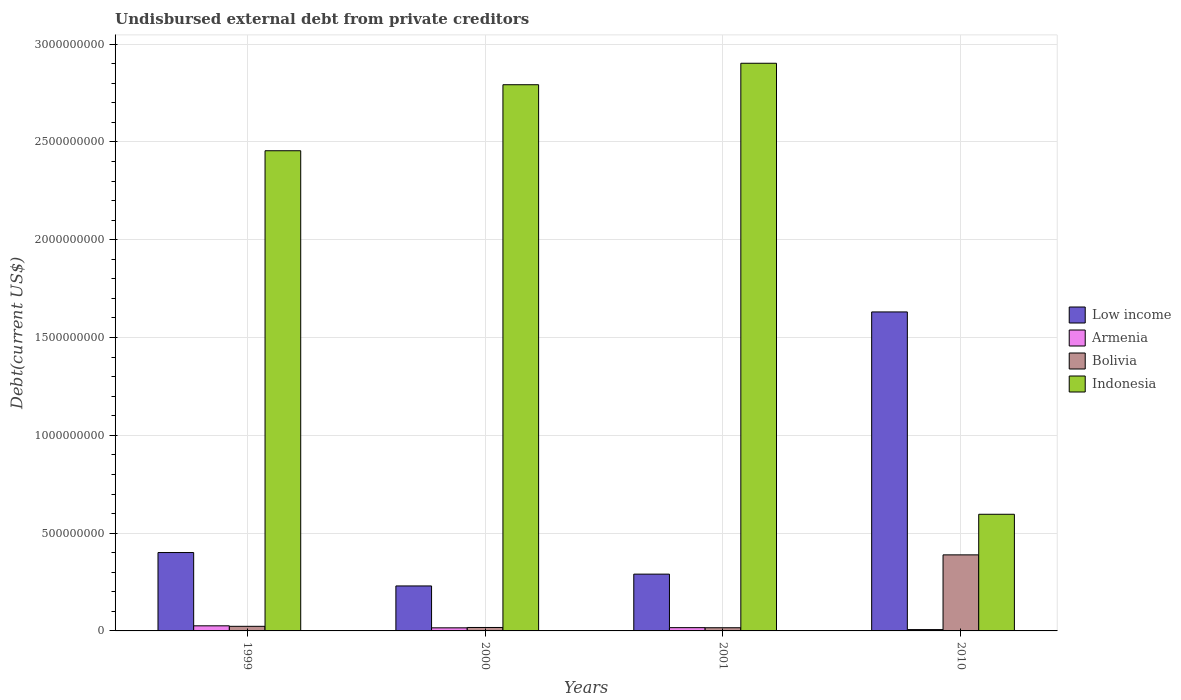Are the number of bars per tick equal to the number of legend labels?
Make the answer very short. Yes. How many bars are there on the 3rd tick from the left?
Provide a short and direct response. 4. What is the label of the 2nd group of bars from the left?
Provide a short and direct response. 2000. In how many cases, is the number of bars for a given year not equal to the number of legend labels?
Make the answer very short. 0. What is the total debt in Armenia in 2010?
Offer a terse response. 6.79e+06. Across all years, what is the maximum total debt in Low income?
Your response must be concise. 1.63e+09. Across all years, what is the minimum total debt in Low income?
Offer a very short reply. 2.30e+08. In which year was the total debt in Low income maximum?
Offer a terse response. 2010. What is the total total debt in Armenia in the graph?
Your answer should be very brief. 6.54e+07. What is the difference between the total debt in Armenia in 2000 and that in 2010?
Offer a terse response. 8.96e+06. What is the difference between the total debt in Indonesia in 2010 and the total debt in Bolivia in 1999?
Offer a very short reply. 5.73e+08. What is the average total debt in Low income per year?
Provide a short and direct response. 6.38e+08. In the year 2000, what is the difference between the total debt in Armenia and total debt in Low income?
Provide a short and direct response. -2.14e+08. What is the ratio of the total debt in Armenia in 1999 to that in 2010?
Offer a terse response. 3.85. Is the total debt in Bolivia in 2001 less than that in 2010?
Your answer should be very brief. Yes. What is the difference between the highest and the second highest total debt in Indonesia?
Your answer should be compact. 1.10e+08. What is the difference between the highest and the lowest total debt in Armenia?
Ensure brevity in your answer.  1.93e+07. Is it the case that in every year, the sum of the total debt in Armenia and total debt in Low income is greater than the sum of total debt in Bolivia and total debt in Indonesia?
Your answer should be compact. No. What does the 3rd bar from the left in 1999 represents?
Your answer should be compact. Bolivia. What does the 3rd bar from the right in 2001 represents?
Your answer should be compact. Armenia. How many bars are there?
Offer a very short reply. 16. Are all the bars in the graph horizontal?
Make the answer very short. No. What is the difference between two consecutive major ticks on the Y-axis?
Offer a very short reply. 5.00e+08. Does the graph contain any zero values?
Offer a terse response. No. What is the title of the graph?
Keep it short and to the point. Undisbursed external debt from private creditors. What is the label or title of the X-axis?
Your answer should be compact. Years. What is the label or title of the Y-axis?
Make the answer very short. Debt(current US$). What is the Debt(current US$) of Low income in 1999?
Your answer should be compact. 4.01e+08. What is the Debt(current US$) in Armenia in 1999?
Give a very brief answer. 2.61e+07. What is the Debt(current US$) of Bolivia in 1999?
Make the answer very short. 2.35e+07. What is the Debt(current US$) in Indonesia in 1999?
Give a very brief answer. 2.45e+09. What is the Debt(current US$) of Low income in 2000?
Your response must be concise. 2.30e+08. What is the Debt(current US$) in Armenia in 2000?
Your response must be concise. 1.58e+07. What is the Debt(current US$) in Bolivia in 2000?
Offer a very short reply. 1.76e+07. What is the Debt(current US$) of Indonesia in 2000?
Your answer should be very brief. 2.79e+09. What is the Debt(current US$) in Low income in 2001?
Keep it short and to the point. 2.90e+08. What is the Debt(current US$) in Armenia in 2001?
Make the answer very short. 1.67e+07. What is the Debt(current US$) in Bolivia in 2001?
Provide a succinct answer. 1.63e+07. What is the Debt(current US$) in Indonesia in 2001?
Give a very brief answer. 2.90e+09. What is the Debt(current US$) of Low income in 2010?
Your response must be concise. 1.63e+09. What is the Debt(current US$) of Armenia in 2010?
Keep it short and to the point. 6.79e+06. What is the Debt(current US$) in Bolivia in 2010?
Offer a very short reply. 3.89e+08. What is the Debt(current US$) of Indonesia in 2010?
Offer a very short reply. 5.96e+08. Across all years, what is the maximum Debt(current US$) in Low income?
Provide a succinct answer. 1.63e+09. Across all years, what is the maximum Debt(current US$) of Armenia?
Provide a short and direct response. 2.61e+07. Across all years, what is the maximum Debt(current US$) in Bolivia?
Provide a succinct answer. 3.89e+08. Across all years, what is the maximum Debt(current US$) of Indonesia?
Your answer should be very brief. 2.90e+09. Across all years, what is the minimum Debt(current US$) of Low income?
Make the answer very short. 2.30e+08. Across all years, what is the minimum Debt(current US$) in Armenia?
Your answer should be very brief. 6.79e+06. Across all years, what is the minimum Debt(current US$) in Bolivia?
Your response must be concise. 1.63e+07. Across all years, what is the minimum Debt(current US$) in Indonesia?
Your response must be concise. 5.96e+08. What is the total Debt(current US$) of Low income in the graph?
Keep it short and to the point. 2.55e+09. What is the total Debt(current US$) of Armenia in the graph?
Provide a short and direct response. 6.54e+07. What is the total Debt(current US$) of Bolivia in the graph?
Offer a very short reply. 4.46e+08. What is the total Debt(current US$) in Indonesia in the graph?
Your answer should be very brief. 8.75e+09. What is the difference between the Debt(current US$) of Low income in 1999 and that in 2000?
Keep it short and to the point. 1.71e+08. What is the difference between the Debt(current US$) in Armenia in 1999 and that in 2000?
Give a very brief answer. 1.04e+07. What is the difference between the Debt(current US$) of Bolivia in 1999 and that in 2000?
Your answer should be very brief. 5.89e+06. What is the difference between the Debt(current US$) of Indonesia in 1999 and that in 2000?
Make the answer very short. -3.38e+08. What is the difference between the Debt(current US$) in Low income in 1999 and that in 2001?
Offer a very short reply. 1.10e+08. What is the difference between the Debt(current US$) in Armenia in 1999 and that in 2001?
Give a very brief answer. 9.39e+06. What is the difference between the Debt(current US$) of Bolivia in 1999 and that in 2001?
Give a very brief answer. 7.24e+06. What is the difference between the Debt(current US$) of Indonesia in 1999 and that in 2001?
Offer a terse response. -4.47e+08. What is the difference between the Debt(current US$) in Low income in 1999 and that in 2010?
Make the answer very short. -1.23e+09. What is the difference between the Debt(current US$) of Armenia in 1999 and that in 2010?
Your response must be concise. 1.93e+07. What is the difference between the Debt(current US$) in Bolivia in 1999 and that in 2010?
Your answer should be compact. -3.65e+08. What is the difference between the Debt(current US$) of Indonesia in 1999 and that in 2010?
Offer a terse response. 1.86e+09. What is the difference between the Debt(current US$) of Low income in 2000 and that in 2001?
Offer a very short reply. -6.04e+07. What is the difference between the Debt(current US$) of Armenia in 2000 and that in 2001?
Provide a succinct answer. -9.60e+05. What is the difference between the Debt(current US$) of Bolivia in 2000 and that in 2001?
Keep it short and to the point. 1.35e+06. What is the difference between the Debt(current US$) of Indonesia in 2000 and that in 2001?
Provide a succinct answer. -1.10e+08. What is the difference between the Debt(current US$) of Low income in 2000 and that in 2010?
Your answer should be compact. -1.40e+09. What is the difference between the Debt(current US$) of Armenia in 2000 and that in 2010?
Your answer should be very brief. 8.96e+06. What is the difference between the Debt(current US$) of Bolivia in 2000 and that in 2010?
Ensure brevity in your answer.  -3.71e+08. What is the difference between the Debt(current US$) in Indonesia in 2000 and that in 2010?
Your response must be concise. 2.20e+09. What is the difference between the Debt(current US$) in Low income in 2001 and that in 2010?
Your response must be concise. -1.34e+09. What is the difference between the Debt(current US$) of Armenia in 2001 and that in 2010?
Make the answer very short. 9.92e+06. What is the difference between the Debt(current US$) of Bolivia in 2001 and that in 2010?
Your response must be concise. -3.73e+08. What is the difference between the Debt(current US$) of Indonesia in 2001 and that in 2010?
Your answer should be compact. 2.31e+09. What is the difference between the Debt(current US$) of Low income in 1999 and the Debt(current US$) of Armenia in 2000?
Your answer should be very brief. 3.85e+08. What is the difference between the Debt(current US$) in Low income in 1999 and the Debt(current US$) in Bolivia in 2000?
Give a very brief answer. 3.83e+08. What is the difference between the Debt(current US$) of Low income in 1999 and the Debt(current US$) of Indonesia in 2000?
Your response must be concise. -2.39e+09. What is the difference between the Debt(current US$) in Armenia in 1999 and the Debt(current US$) in Bolivia in 2000?
Offer a terse response. 8.48e+06. What is the difference between the Debt(current US$) in Armenia in 1999 and the Debt(current US$) in Indonesia in 2000?
Give a very brief answer. -2.77e+09. What is the difference between the Debt(current US$) of Bolivia in 1999 and the Debt(current US$) of Indonesia in 2000?
Your response must be concise. -2.77e+09. What is the difference between the Debt(current US$) of Low income in 1999 and the Debt(current US$) of Armenia in 2001?
Ensure brevity in your answer.  3.84e+08. What is the difference between the Debt(current US$) of Low income in 1999 and the Debt(current US$) of Bolivia in 2001?
Your answer should be very brief. 3.84e+08. What is the difference between the Debt(current US$) of Low income in 1999 and the Debt(current US$) of Indonesia in 2001?
Keep it short and to the point. -2.50e+09. What is the difference between the Debt(current US$) of Armenia in 1999 and the Debt(current US$) of Bolivia in 2001?
Ensure brevity in your answer.  9.84e+06. What is the difference between the Debt(current US$) in Armenia in 1999 and the Debt(current US$) in Indonesia in 2001?
Your answer should be compact. -2.88e+09. What is the difference between the Debt(current US$) in Bolivia in 1999 and the Debt(current US$) in Indonesia in 2001?
Give a very brief answer. -2.88e+09. What is the difference between the Debt(current US$) in Low income in 1999 and the Debt(current US$) in Armenia in 2010?
Make the answer very short. 3.94e+08. What is the difference between the Debt(current US$) of Low income in 1999 and the Debt(current US$) of Bolivia in 2010?
Provide a succinct answer. 1.19e+07. What is the difference between the Debt(current US$) in Low income in 1999 and the Debt(current US$) in Indonesia in 2010?
Provide a succinct answer. -1.96e+08. What is the difference between the Debt(current US$) of Armenia in 1999 and the Debt(current US$) of Bolivia in 2010?
Provide a succinct answer. -3.63e+08. What is the difference between the Debt(current US$) of Armenia in 1999 and the Debt(current US$) of Indonesia in 2010?
Offer a terse response. -5.70e+08. What is the difference between the Debt(current US$) of Bolivia in 1999 and the Debt(current US$) of Indonesia in 2010?
Your answer should be very brief. -5.73e+08. What is the difference between the Debt(current US$) of Low income in 2000 and the Debt(current US$) of Armenia in 2001?
Your answer should be compact. 2.13e+08. What is the difference between the Debt(current US$) of Low income in 2000 and the Debt(current US$) of Bolivia in 2001?
Offer a very short reply. 2.14e+08. What is the difference between the Debt(current US$) of Low income in 2000 and the Debt(current US$) of Indonesia in 2001?
Offer a terse response. -2.67e+09. What is the difference between the Debt(current US$) in Armenia in 2000 and the Debt(current US$) in Bolivia in 2001?
Make the answer very short. -5.19e+05. What is the difference between the Debt(current US$) of Armenia in 2000 and the Debt(current US$) of Indonesia in 2001?
Make the answer very short. -2.89e+09. What is the difference between the Debt(current US$) of Bolivia in 2000 and the Debt(current US$) of Indonesia in 2001?
Offer a terse response. -2.88e+09. What is the difference between the Debt(current US$) in Low income in 2000 and the Debt(current US$) in Armenia in 2010?
Ensure brevity in your answer.  2.23e+08. What is the difference between the Debt(current US$) in Low income in 2000 and the Debt(current US$) in Bolivia in 2010?
Make the answer very short. -1.59e+08. What is the difference between the Debt(current US$) of Low income in 2000 and the Debt(current US$) of Indonesia in 2010?
Offer a terse response. -3.66e+08. What is the difference between the Debt(current US$) in Armenia in 2000 and the Debt(current US$) in Bolivia in 2010?
Your answer should be compact. -3.73e+08. What is the difference between the Debt(current US$) in Armenia in 2000 and the Debt(current US$) in Indonesia in 2010?
Make the answer very short. -5.81e+08. What is the difference between the Debt(current US$) of Bolivia in 2000 and the Debt(current US$) of Indonesia in 2010?
Your response must be concise. -5.79e+08. What is the difference between the Debt(current US$) of Low income in 2001 and the Debt(current US$) of Armenia in 2010?
Make the answer very short. 2.84e+08. What is the difference between the Debt(current US$) in Low income in 2001 and the Debt(current US$) in Bolivia in 2010?
Offer a very short reply. -9.85e+07. What is the difference between the Debt(current US$) of Low income in 2001 and the Debt(current US$) of Indonesia in 2010?
Offer a very short reply. -3.06e+08. What is the difference between the Debt(current US$) in Armenia in 2001 and the Debt(current US$) in Bolivia in 2010?
Your answer should be compact. -3.72e+08. What is the difference between the Debt(current US$) of Armenia in 2001 and the Debt(current US$) of Indonesia in 2010?
Provide a succinct answer. -5.80e+08. What is the difference between the Debt(current US$) of Bolivia in 2001 and the Debt(current US$) of Indonesia in 2010?
Your answer should be compact. -5.80e+08. What is the average Debt(current US$) in Low income per year?
Make the answer very short. 6.38e+08. What is the average Debt(current US$) in Armenia per year?
Give a very brief answer. 1.63e+07. What is the average Debt(current US$) of Bolivia per year?
Offer a very short reply. 1.12e+08. What is the average Debt(current US$) of Indonesia per year?
Your answer should be very brief. 2.19e+09. In the year 1999, what is the difference between the Debt(current US$) of Low income and Debt(current US$) of Armenia?
Provide a short and direct response. 3.75e+08. In the year 1999, what is the difference between the Debt(current US$) in Low income and Debt(current US$) in Bolivia?
Provide a short and direct response. 3.77e+08. In the year 1999, what is the difference between the Debt(current US$) in Low income and Debt(current US$) in Indonesia?
Your answer should be compact. -2.05e+09. In the year 1999, what is the difference between the Debt(current US$) in Armenia and Debt(current US$) in Bolivia?
Your answer should be compact. 2.59e+06. In the year 1999, what is the difference between the Debt(current US$) in Armenia and Debt(current US$) in Indonesia?
Your answer should be very brief. -2.43e+09. In the year 1999, what is the difference between the Debt(current US$) of Bolivia and Debt(current US$) of Indonesia?
Provide a succinct answer. -2.43e+09. In the year 2000, what is the difference between the Debt(current US$) of Low income and Debt(current US$) of Armenia?
Provide a short and direct response. 2.14e+08. In the year 2000, what is the difference between the Debt(current US$) of Low income and Debt(current US$) of Bolivia?
Ensure brevity in your answer.  2.12e+08. In the year 2000, what is the difference between the Debt(current US$) of Low income and Debt(current US$) of Indonesia?
Provide a succinct answer. -2.56e+09. In the year 2000, what is the difference between the Debt(current US$) of Armenia and Debt(current US$) of Bolivia?
Keep it short and to the point. -1.87e+06. In the year 2000, what is the difference between the Debt(current US$) of Armenia and Debt(current US$) of Indonesia?
Offer a very short reply. -2.78e+09. In the year 2000, what is the difference between the Debt(current US$) in Bolivia and Debt(current US$) in Indonesia?
Your answer should be compact. -2.77e+09. In the year 2001, what is the difference between the Debt(current US$) of Low income and Debt(current US$) of Armenia?
Ensure brevity in your answer.  2.74e+08. In the year 2001, what is the difference between the Debt(current US$) of Low income and Debt(current US$) of Bolivia?
Keep it short and to the point. 2.74e+08. In the year 2001, what is the difference between the Debt(current US$) in Low income and Debt(current US$) in Indonesia?
Your answer should be compact. -2.61e+09. In the year 2001, what is the difference between the Debt(current US$) of Armenia and Debt(current US$) of Bolivia?
Ensure brevity in your answer.  4.41e+05. In the year 2001, what is the difference between the Debt(current US$) of Armenia and Debt(current US$) of Indonesia?
Provide a short and direct response. -2.89e+09. In the year 2001, what is the difference between the Debt(current US$) of Bolivia and Debt(current US$) of Indonesia?
Your response must be concise. -2.89e+09. In the year 2010, what is the difference between the Debt(current US$) in Low income and Debt(current US$) in Armenia?
Your answer should be compact. 1.62e+09. In the year 2010, what is the difference between the Debt(current US$) of Low income and Debt(current US$) of Bolivia?
Your answer should be compact. 1.24e+09. In the year 2010, what is the difference between the Debt(current US$) in Low income and Debt(current US$) in Indonesia?
Give a very brief answer. 1.03e+09. In the year 2010, what is the difference between the Debt(current US$) in Armenia and Debt(current US$) in Bolivia?
Offer a terse response. -3.82e+08. In the year 2010, what is the difference between the Debt(current US$) in Armenia and Debt(current US$) in Indonesia?
Provide a short and direct response. -5.90e+08. In the year 2010, what is the difference between the Debt(current US$) of Bolivia and Debt(current US$) of Indonesia?
Give a very brief answer. -2.07e+08. What is the ratio of the Debt(current US$) of Low income in 1999 to that in 2000?
Your answer should be very brief. 1.74. What is the ratio of the Debt(current US$) of Armenia in 1999 to that in 2000?
Offer a very short reply. 1.66. What is the ratio of the Debt(current US$) of Bolivia in 1999 to that in 2000?
Keep it short and to the point. 1.33. What is the ratio of the Debt(current US$) of Indonesia in 1999 to that in 2000?
Ensure brevity in your answer.  0.88. What is the ratio of the Debt(current US$) in Low income in 1999 to that in 2001?
Offer a very short reply. 1.38. What is the ratio of the Debt(current US$) in Armenia in 1999 to that in 2001?
Your answer should be compact. 1.56. What is the ratio of the Debt(current US$) in Bolivia in 1999 to that in 2001?
Give a very brief answer. 1.45. What is the ratio of the Debt(current US$) of Indonesia in 1999 to that in 2001?
Your answer should be compact. 0.85. What is the ratio of the Debt(current US$) of Low income in 1999 to that in 2010?
Provide a short and direct response. 0.25. What is the ratio of the Debt(current US$) of Armenia in 1999 to that in 2010?
Make the answer very short. 3.85. What is the ratio of the Debt(current US$) in Bolivia in 1999 to that in 2010?
Your response must be concise. 0.06. What is the ratio of the Debt(current US$) of Indonesia in 1999 to that in 2010?
Offer a very short reply. 4.12. What is the ratio of the Debt(current US$) in Low income in 2000 to that in 2001?
Ensure brevity in your answer.  0.79. What is the ratio of the Debt(current US$) in Armenia in 2000 to that in 2001?
Offer a terse response. 0.94. What is the ratio of the Debt(current US$) of Bolivia in 2000 to that in 2001?
Make the answer very short. 1.08. What is the ratio of the Debt(current US$) of Indonesia in 2000 to that in 2001?
Ensure brevity in your answer.  0.96. What is the ratio of the Debt(current US$) in Low income in 2000 to that in 2010?
Provide a succinct answer. 0.14. What is the ratio of the Debt(current US$) in Armenia in 2000 to that in 2010?
Your answer should be very brief. 2.32. What is the ratio of the Debt(current US$) of Bolivia in 2000 to that in 2010?
Offer a very short reply. 0.05. What is the ratio of the Debt(current US$) in Indonesia in 2000 to that in 2010?
Provide a succinct answer. 4.68. What is the ratio of the Debt(current US$) in Low income in 2001 to that in 2010?
Offer a very short reply. 0.18. What is the ratio of the Debt(current US$) in Armenia in 2001 to that in 2010?
Make the answer very short. 2.46. What is the ratio of the Debt(current US$) of Bolivia in 2001 to that in 2010?
Ensure brevity in your answer.  0.04. What is the ratio of the Debt(current US$) in Indonesia in 2001 to that in 2010?
Provide a short and direct response. 4.87. What is the difference between the highest and the second highest Debt(current US$) of Low income?
Provide a succinct answer. 1.23e+09. What is the difference between the highest and the second highest Debt(current US$) of Armenia?
Provide a short and direct response. 9.39e+06. What is the difference between the highest and the second highest Debt(current US$) in Bolivia?
Give a very brief answer. 3.65e+08. What is the difference between the highest and the second highest Debt(current US$) in Indonesia?
Keep it short and to the point. 1.10e+08. What is the difference between the highest and the lowest Debt(current US$) of Low income?
Your response must be concise. 1.40e+09. What is the difference between the highest and the lowest Debt(current US$) in Armenia?
Provide a short and direct response. 1.93e+07. What is the difference between the highest and the lowest Debt(current US$) of Bolivia?
Make the answer very short. 3.73e+08. What is the difference between the highest and the lowest Debt(current US$) of Indonesia?
Make the answer very short. 2.31e+09. 